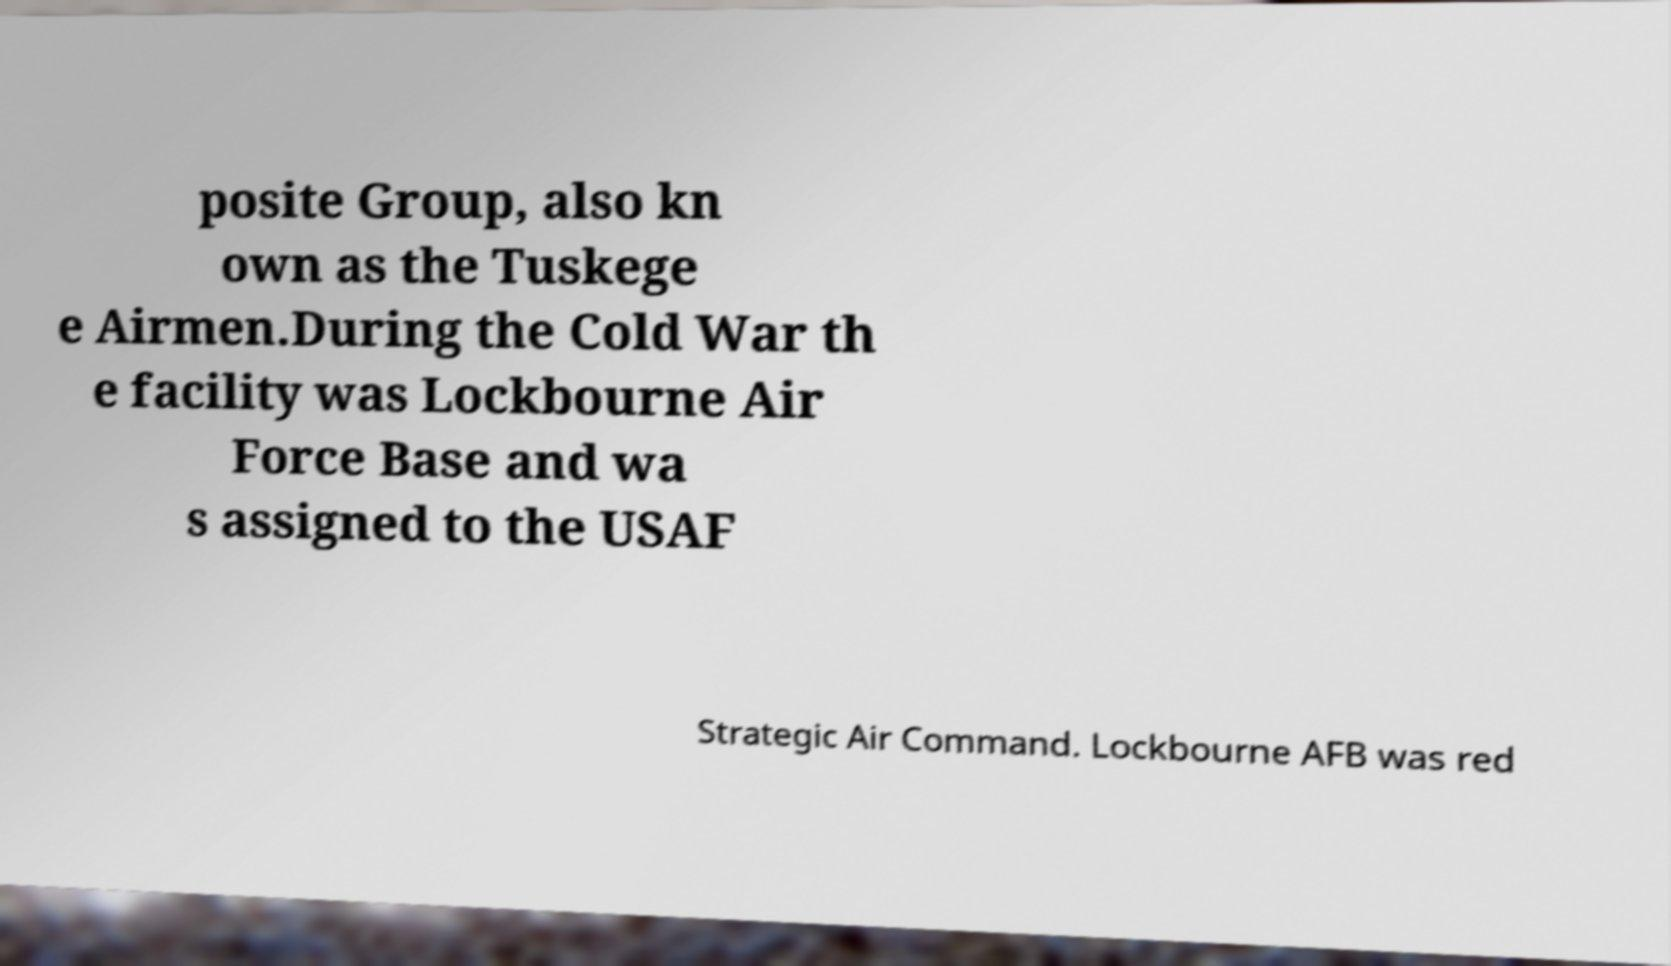Please read and relay the text visible in this image. What does it say? posite Group, also kn own as the Tuskege e Airmen.During the Cold War th e facility was Lockbourne Air Force Base and wa s assigned to the USAF Strategic Air Command. Lockbourne AFB was red 